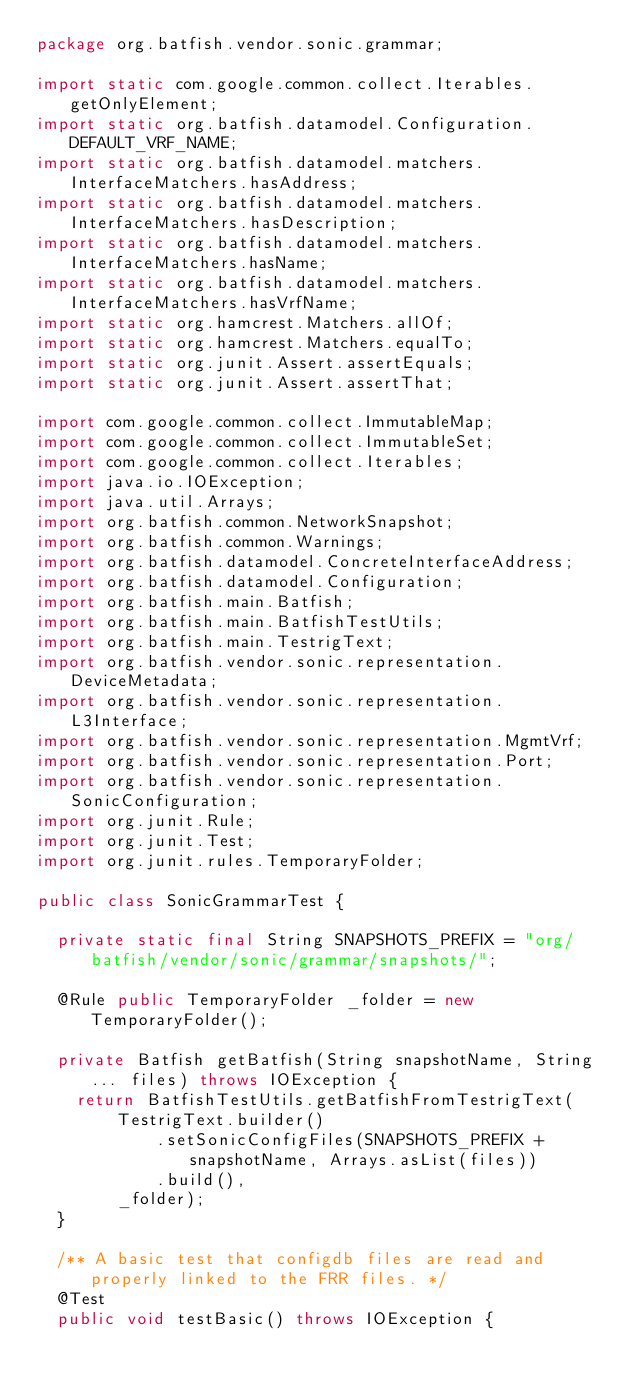<code> <loc_0><loc_0><loc_500><loc_500><_Java_>package org.batfish.vendor.sonic.grammar;

import static com.google.common.collect.Iterables.getOnlyElement;
import static org.batfish.datamodel.Configuration.DEFAULT_VRF_NAME;
import static org.batfish.datamodel.matchers.InterfaceMatchers.hasAddress;
import static org.batfish.datamodel.matchers.InterfaceMatchers.hasDescription;
import static org.batfish.datamodel.matchers.InterfaceMatchers.hasName;
import static org.batfish.datamodel.matchers.InterfaceMatchers.hasVrfName;
import static org.hamcrest.Matchers.allOf;
import static org.hamcrest.Matchers.equalTo;
import static org.junit.Assert.assertEquals;
import static org.junit.Assert.assertThat;

import com.google.common.collect.ImmutableMap;
import com.google.common.collect.ImmutableSet;
import com.google.common.collect.Iterables;
import java.io.IOException;
import java.util.Arrays;
import org.batfish.common.NetworkSnapshot;
import org.batfish.common.Warnings;
import org.batfish.datamodel.ConcreteInterfaceAddress;
import org.batfish.datamodel.Configuration;
import org.batfish.main.Batfish;
import org.batfish.main.BatfishTestUtils;
import org.batfish.main.TestrigText;
import org.batfish.vendor.sonic.representation.DeviceMetadata;
import org.batfish.vendor.sonic.representation.L3Interface;
import org.batfish.vendor.sonic.representation.MgmtVrf;
import org.batfish.vendor.sonic.representation.Port;
import org.batfish.vendor.sonic.representation.SonicConfiguration;
import org.junit.Rule;
import org.junit.Test;
import org.junit.rules.TemporaryFolder;

public class SonicGrammarTest {

  private static final String SNAPSHOTS_PREFIX = "org/batfish/vendor/sonic/grammar/snapshots/";

  @Rule public TemporaryFolder _folder = new TemporaryFolder();

  private Batfish getBatfish(String snapshotName, String... files) throws IOException {
    return BatfishTestUtils.getBatfishFromTestrigText(
        TestrigText.builder()
            .setSonicConfigFiles(SNAPSHOTS_PREFIX + snapshotName, Arrays.asList(files))
            .build(),
        _folder);
  }

  /** A basic test that configdb files are read and properly linked to the FRR files. */
  @Test
  public void testBasic() throws IOException {</code> 